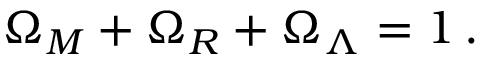<formula> <loc_0><loc_0><loc_500><loc_500>\Omega _ { M } + \Omega _ { R } + \Omega _ { \Lambda } = 1 \, .</formula> 